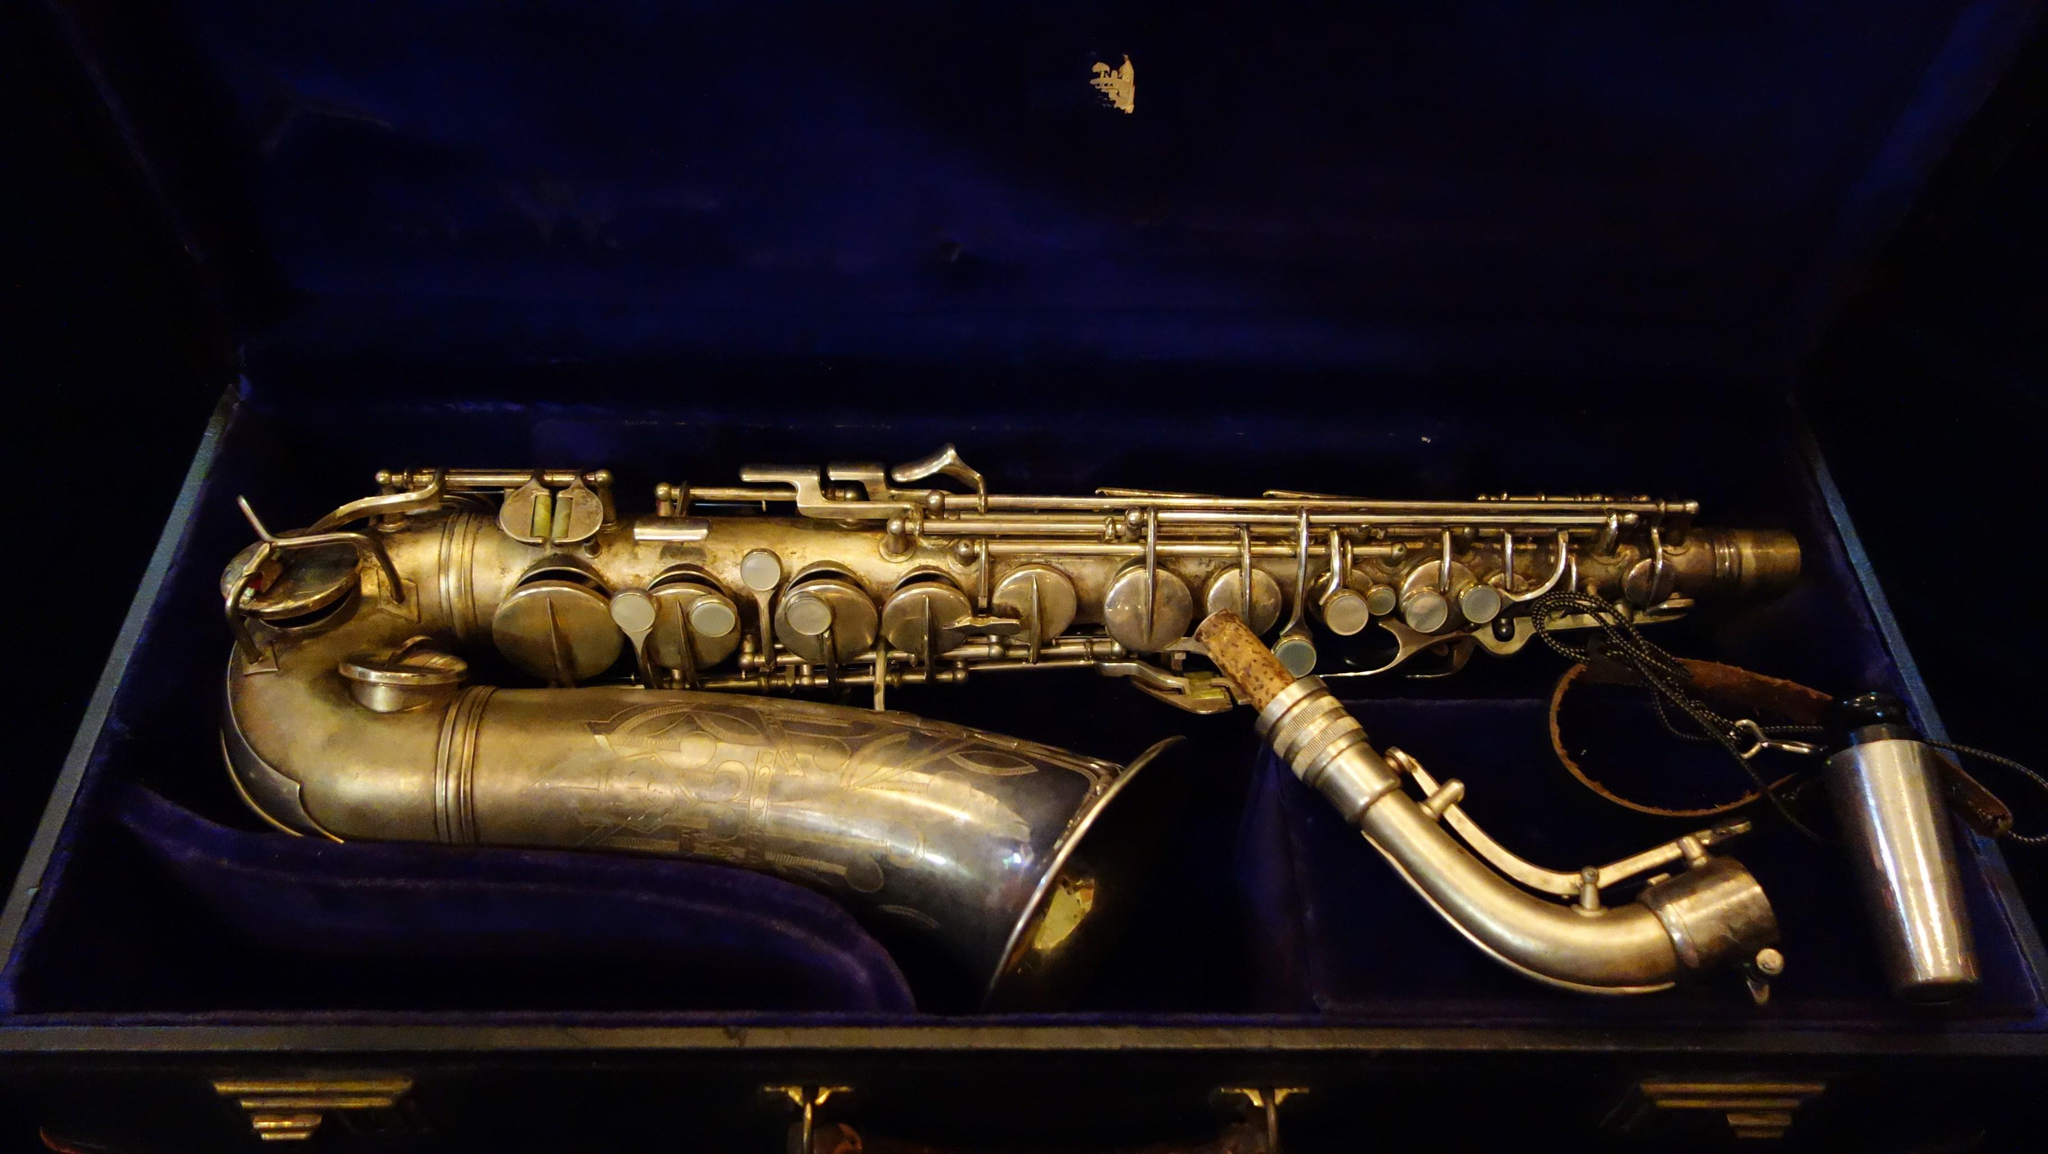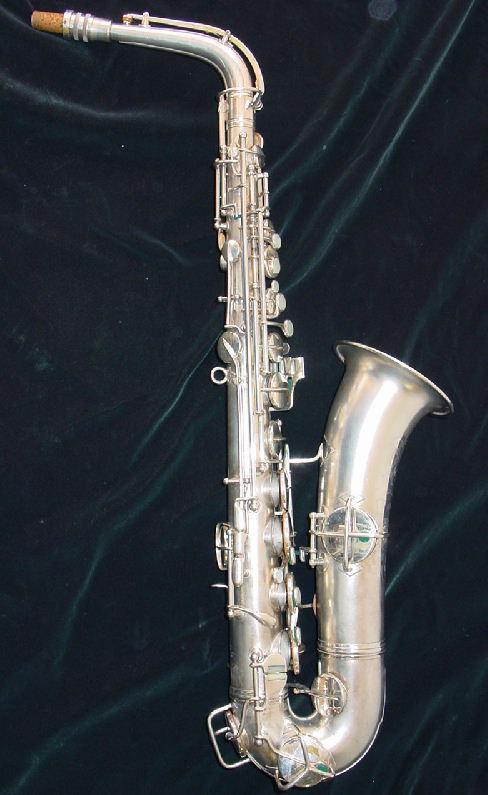The first image is the image on the left, the second image is the image on the right. Given the left and right images, does the statement "The left and right image contains the same number saxophone and one if fully put together while the other is missing it's mouthpiece." hold true? Answer yes or no. Yes. The first image is the image on the left, the second image is the image on the right. Analyze the images presented: Is the assertion "One image shows a saxophone with mouthpiece attached displayed on folds of blue velvet with its bell turned rightward." valid? Answer yes or no. Yes. 